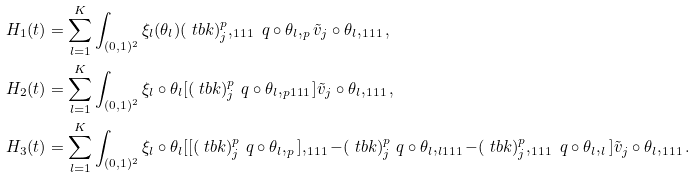Convert formula to latex. <formula><loc_0><loc_0><loc_500><loc_500>H _ { 1 } ( t ) & = \sum _ { l = 1 } ^ { K } \int _ { ( 0 , 1 ) ^ { 2 } } \xi _ { l } ( \theta _ { l } ) ( \ t b k ) _ { j } ^ { p } , _ { 1 1 1 } \ q \circ \theta _ { l } , _ { p } { \tilde { v } } _ { j } \circ \theta _ { l } , _ { 1 1 1 } , \\ H _ { 2 } ( t ) & = \sum _ { l = 1 } ^ { K } \int _ { ( 0 , 1 ) ^ { 2 } } \xi _ { l } \circ \theta _ { l } [ ( \ t b k ) _ { j } ^ { p } \ q \circ \theta _ { l } , _ { p 1 1 1 } ] { \tilde { v } } _ { j } \circ \theta _ { l } , _ { 1 1 1 } , \\ H _ { 3 } ( t ) & = \sum _ { l = 1 } ^ { K } \int _ { ( 0 , 1 ) ^ { 2 } } \xi _ { l } \circ \theta _ { l } [ [ ( \ t b k ) _ { j } ^ { p } \ q \circ \theta _ { l } , _ { p } ] , _ { 1 1 1 } - ( \ t b k ) _ { j } ^ { p } \ q \circ \theta _ { l } , _ { l 1 1 1 } - ( \ t b k ) _ { j } ^ { p } , _ { 1 1 1 } \ q \circ \theta _ { l } , _ { l } ] { \tilde { v } } _ { j } \circ \theta _ { l } , _ { 1 1 1 } .</formula> 